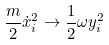Convert formula to latex. <formula><loc_0><loc_0><loc_500><loc_500>\frac { m } { 2 } \dot { x } _ { i } ^ { 2 } \rightarrow \frac { 1 } { 2 } \omega y _ { i } ^ { 2 }</formula> 